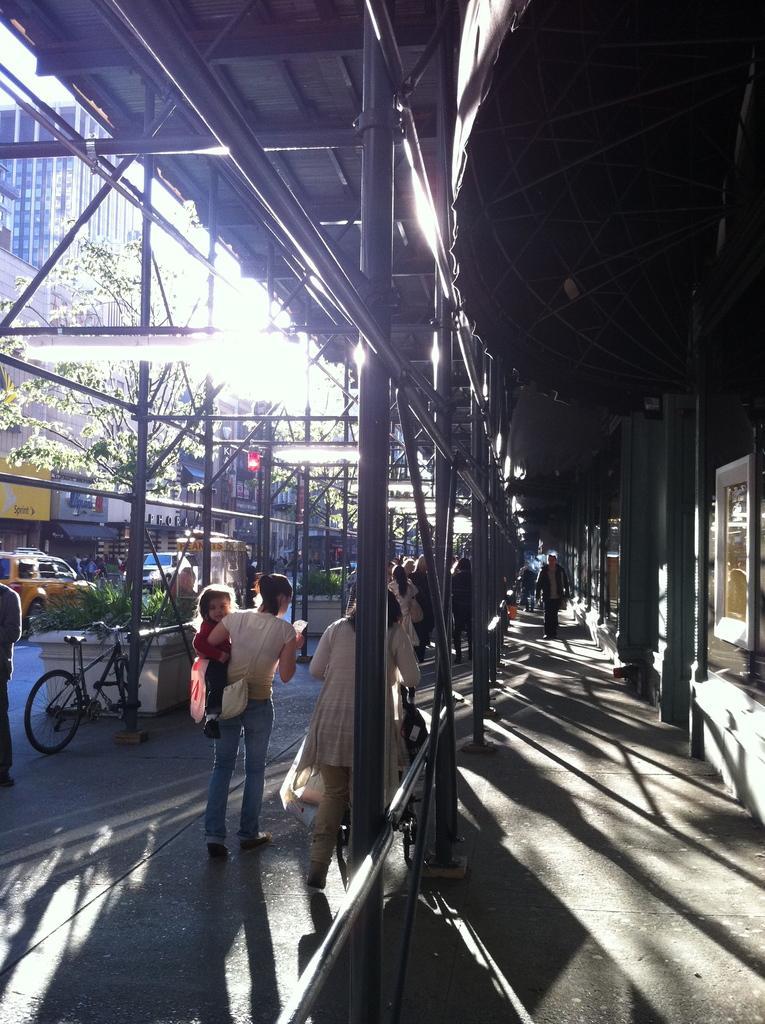Describe this image in one or two sentences. In this image there are few people walking on the road. At the top there is roof. On the left side there are buildings and trees. There are few cars and vehicles on the road. 